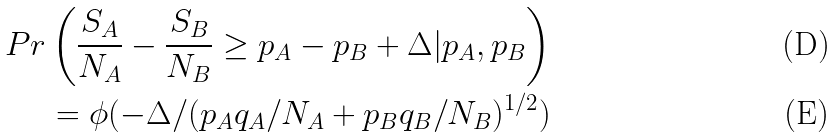Convert formula to latex. <formula><loc_0><loc_0><loc_500><loc_500>P r \left ( \frac { S _ { A } } { N _ { A } } - \frac { S _ { B } } { N _ { B } } \geq p _ { A } - p _ { B } + \Delta | p _ { A } , p _ { B } \right ) \\ = \phi ( - \Delta / ( p _ { A } q _ { A } / N _ { A } + p _ { B } q _ { B } / N _ { B } ) ^ { 1 / 2 } )</formula> 